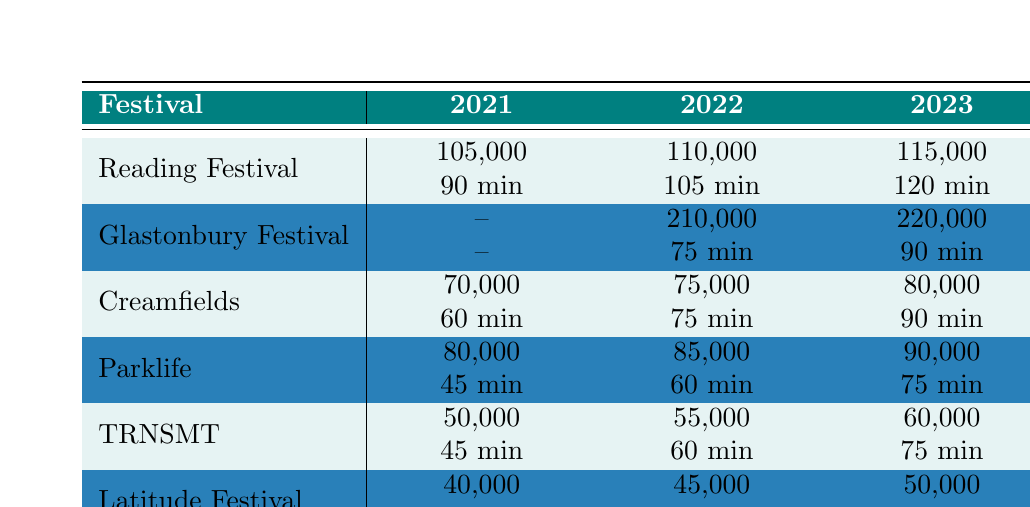What was the attendance at Reading Festival in 2022? The table shows that the attendance for Reading Festival in 2022 was 110,000.
Answer: 110,000 How long was Jack Saunders' set at Creamfields in 2023? According to the table, Jack Saunders' set at Creamfields in 2023 lasted for 90 minutes.
Answer: 90 minutes Which festival had the highest attendance in 2023? The highest attendance in 2023 was 220,000 at Glastonbury Festival, as per the table data.
Answer: Glastonbury Festival What is the set length difference between Parklife in 2021 and 2023? The set length for Parklife in 2021 was 45 minutes and in 2023 it was 75 minutes. The difference is 75 - 45 = 30 minutes.
Answer: 30 minutes Did Jack Saunders perform at Glastonbury Festival in 2021? The table indicates that attendance and set length for Glastonbury Festival in 2021 were both recorded as zero, implying that there was no performance that year.
Answer: No What was the total attendance across all festivals in 2022? Adding the attendances: 110,000 (Reading) + 210,000 (Glastonbury) + 75,000 (Creamfields) + 85,000 (Parklife) + 55,000 (TRNSMT) + 45,000 (Latitude) gives us a total of 580,000 for 2022.
Answer: 580,000 What was the average set length for all festivals in 2021? The set lengths in 2021 were 90 min (Reading), 0 min (Glastonbury), 60 min (Creamfields), 45 min (Parklife), 45 min (TRNSMT), and 60 min (Latitude). Calculating the average: (90 + 0 + 60 + 45 + 45 + 60) / 5 = 300 / 5 = 60 minutes (ignoring the zero for average).
Answer: 60 minutes Which festival showed the most significant increase in attendance from 2021 to 2023? Comparing the attendance figures: Reading increased from 105,000 to 115,000 (10,000 increase), Glastonbury from 0 to 220,000 (220,000 increase), Creamfields from 70,000 to 80,000 (10,000 increase), Parklife from 80,000 to 90,000 (10,000 increase), TRNSMT from 50,000 to 60,000 (10,000 increase), Latitude from 40,000 to 50,000 (10,000 increase). The largest increase was Glastonbury with 220,000 attendees.
Answer: Glastonbury Festival What was Jack Saunders' set length at TRNSMT Festival in 2023 compared to 2022? In 2023, the set length at TRNSMT was 75 minutes and in 2022 it was 60 minutes. This represents an increase of 15 minutes from 2022 to 2023.
Answer: 15 minutes increase Which festival had the lowest attendance in 2021? The table shows that the lowest attendance in 2021 was at Latitude Festival, with 40,000 attendees.
Answer: Latitude Festival 